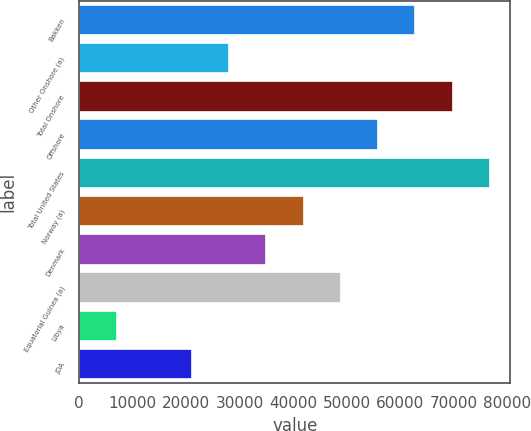Convert chart to OTSL. <chart><loc_0><loc_0><loc_500><loc_500><bar_chart><fcel>Bakken<fcel>Other Onshore (a)<fcel>Total Onshore<fcel>Offshore<fcel>Total United States<fcel>Norway (a)<fcel>Denmark<fcel>Equatorial Guinea (a)<fcel>Libya<fcel>JDA<nl><fcel>62848.7<fcel>28017.2<fcel>69815<fcel>55882.4<fcel>76781.3<fcel>41949.8<fcel>34983.5<fcel>48916.1<fcel>7118.3<fcel>21050.9<nl></chart> 